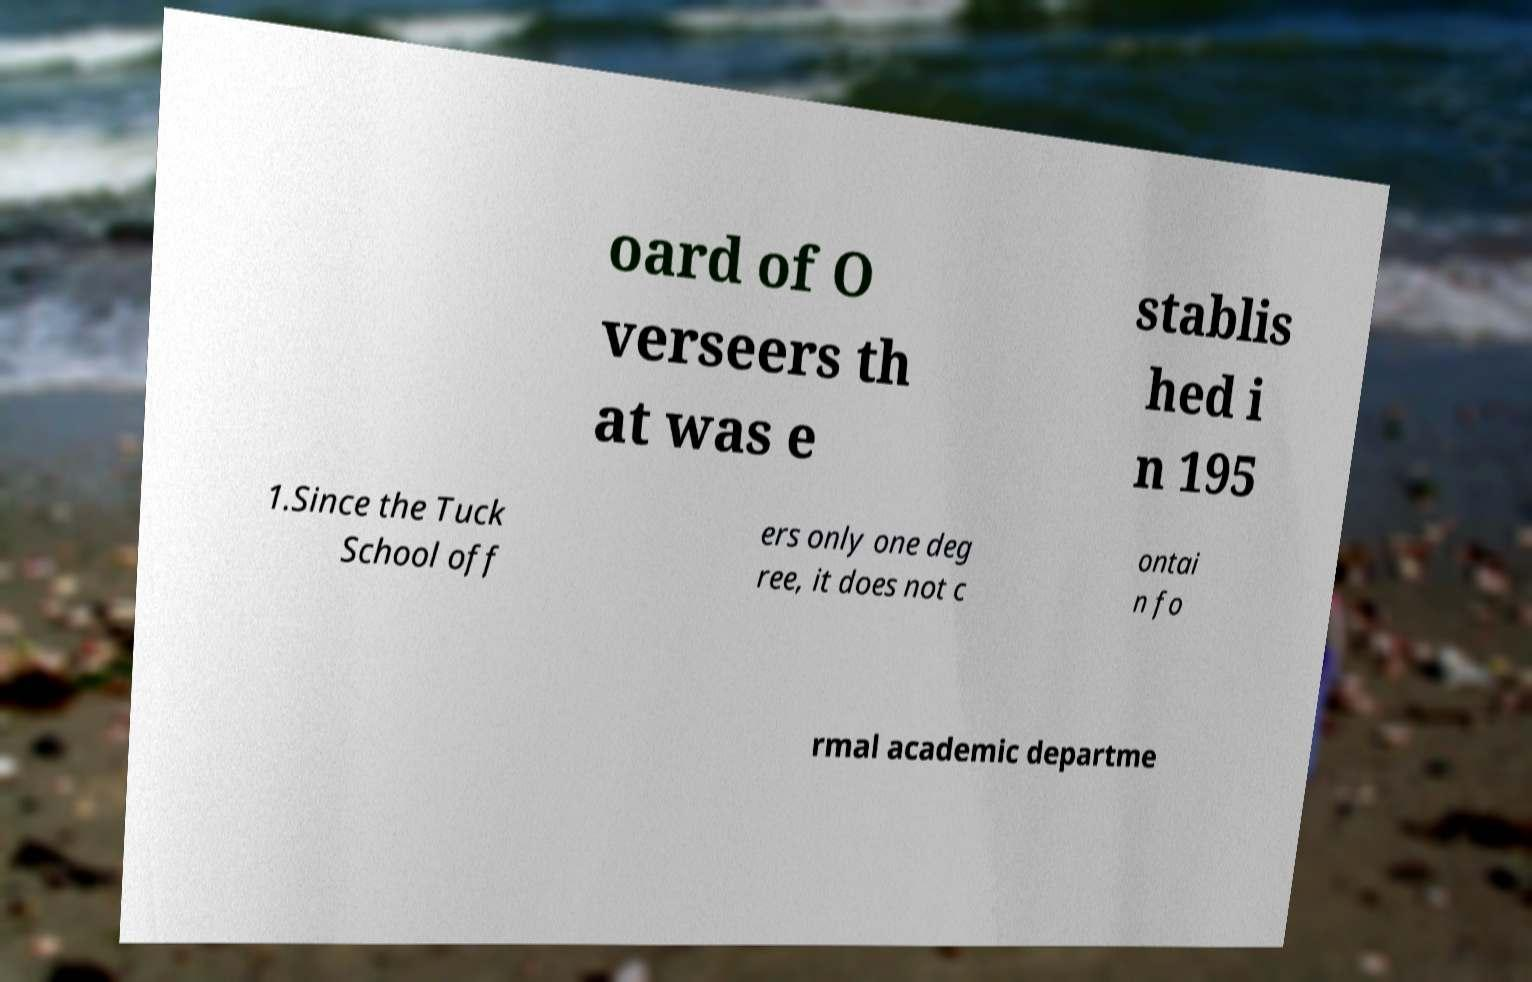There's text embedded in this image that I need extracted. Can you transcribe it verbatim? oard of O verseers th at was e stablis hed i n 195 1.Since the Tuck School off ers only one deg ree, it does not c ontai n fo rmal academic departme 